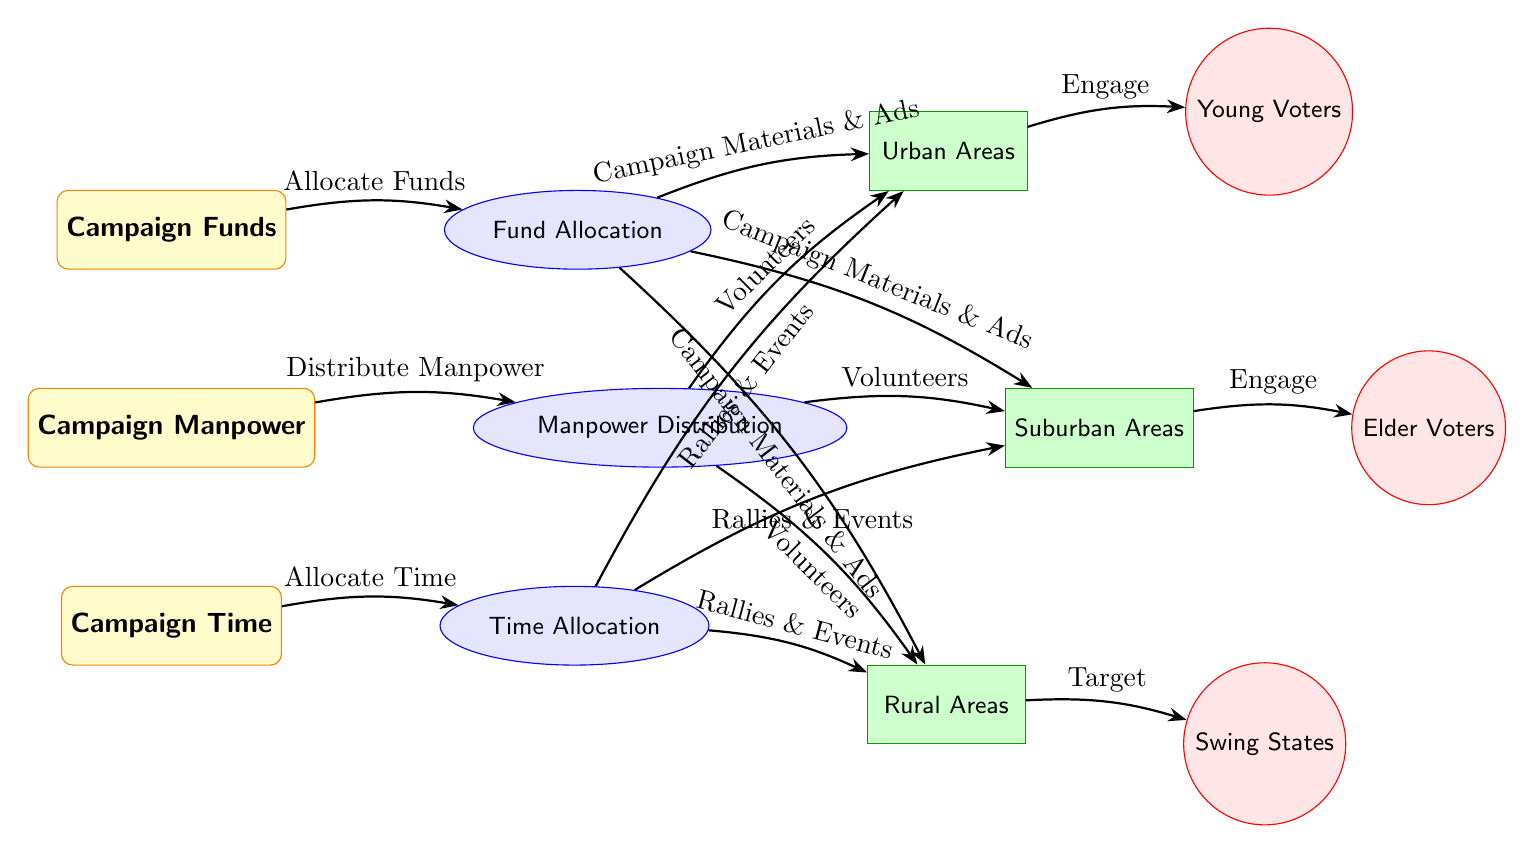What are the three main campaign resources depicted in the diagram? The diagram clearly shows three main resources at the top: Campaign Funds, Campaign Manpower, and Campaign Time. This represents the foundational elements for a campaign's strategy.
Answer: Campaign Funds, Campaign Manpower, Campaign Time How many areas are designated for campaign investment? The diagram highlights three specific areas for campaign investment: Urban Areas, Suburban Areas, and Rural Areas. Each area is indicated by its own rectangle.
Answer: 3 Which demographic is targeted in rural areas? The diagram specifies that Swing States are targeted in rural areas, indicating a strategic demographic focus in those regions. This is represented by an arrow leading from rural areas to swing states.
Answer: Swing States What type of activities is allocated time for in urban areas? According to the diagram, Rallies & Events are allocated time in urban areas. This is shown through the directed edge from Time Allocation to Urban Areas.
Answer: Rallies & Events How is manpower distributed among the different areas? The diagram shows that Manpower Distribution sends volunteers to Urban Areas, Suburban Areas, and Rural Areas, indicating that manpower is equally distributed across all three areas.
Answer: Volunteers in all areas Which area receives campaign material and ads from fund allocation? The diagram illustrates that Campaign Materials & Ads from Fund Allocation are directed towards Urban Areas, Suburban Areas, and Rural Areas, indicating that all areas benefit from these funds.
Answer: All areas What is the relationship between urban areas and young voters? In the diagram, Urban Areas engage with Young Voters, showing an important connection in the campaign strategy aimed at appealing to younger demographics in urban settings.
Answer: Engage What demographic is associated with suburban areas? The diagram clearly links Suburban Areas to Elder Voters, indicating that this demographic is a primary focus for campaign efforts in suburban regions.
Answer: Elder Voters How many edges connect the Campaign Funds to other allocation types? The diagram shows one edge leading from Campaign Funds to Fund Allocation, thus displaying a direct connection for resource allocation.
Answer: 1 